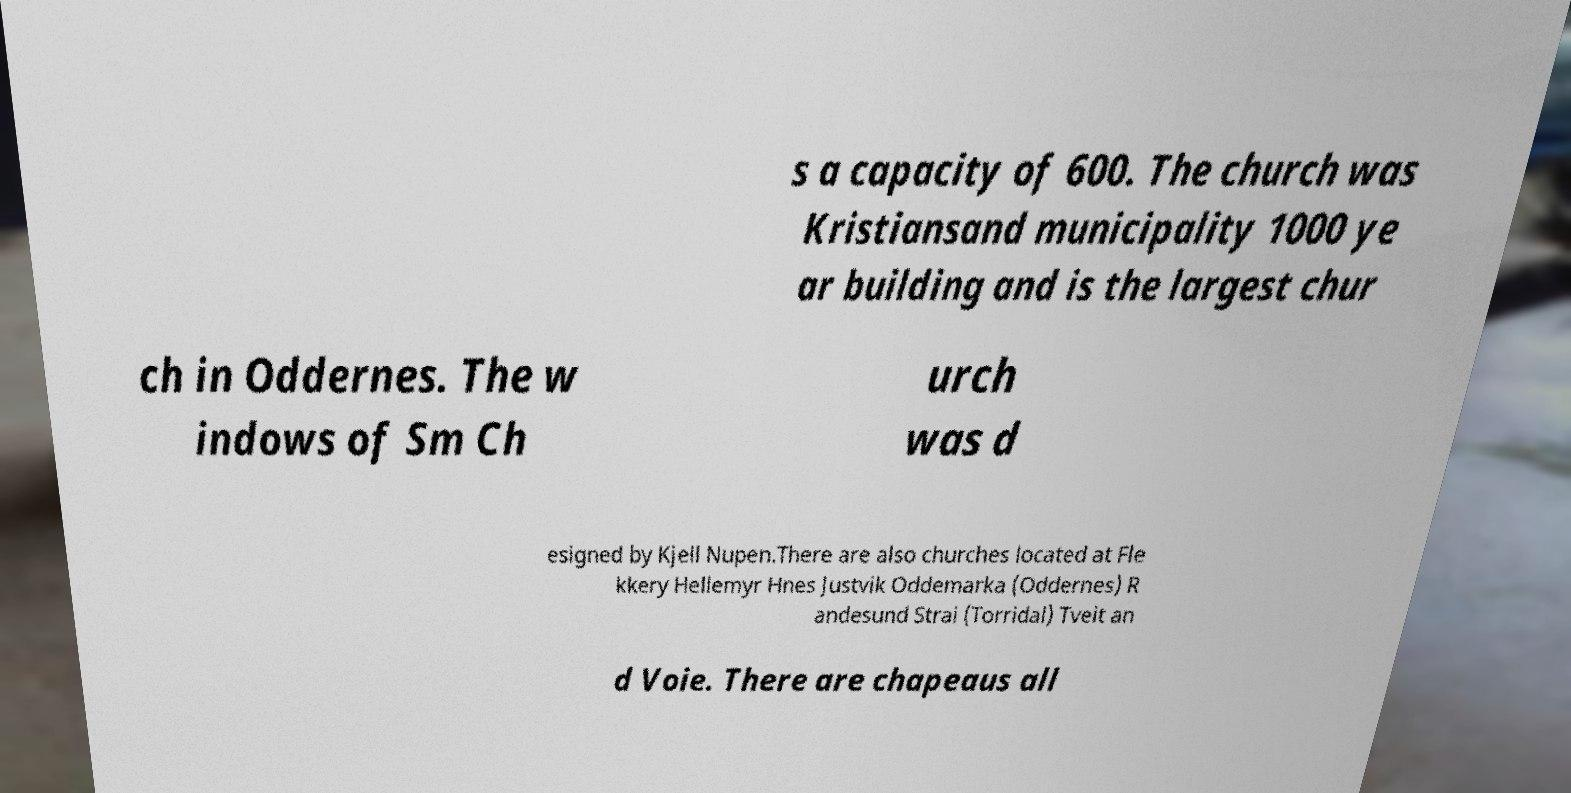Could you extract and type out the text from this image? s a capacity of 600. The church was Kristiansand municipality 1000 ye ar building and is the largest chur ch in Oddernes. The w indows of Sm Ch urch was d esigned by Kjell Nupen.There are also churches located at Fle kkery Hellemyr Hnes Justvik Oddemarka (Oddernes) R andesund Strai (Torridal) Tveit an d Voie. There are chapeaus all 